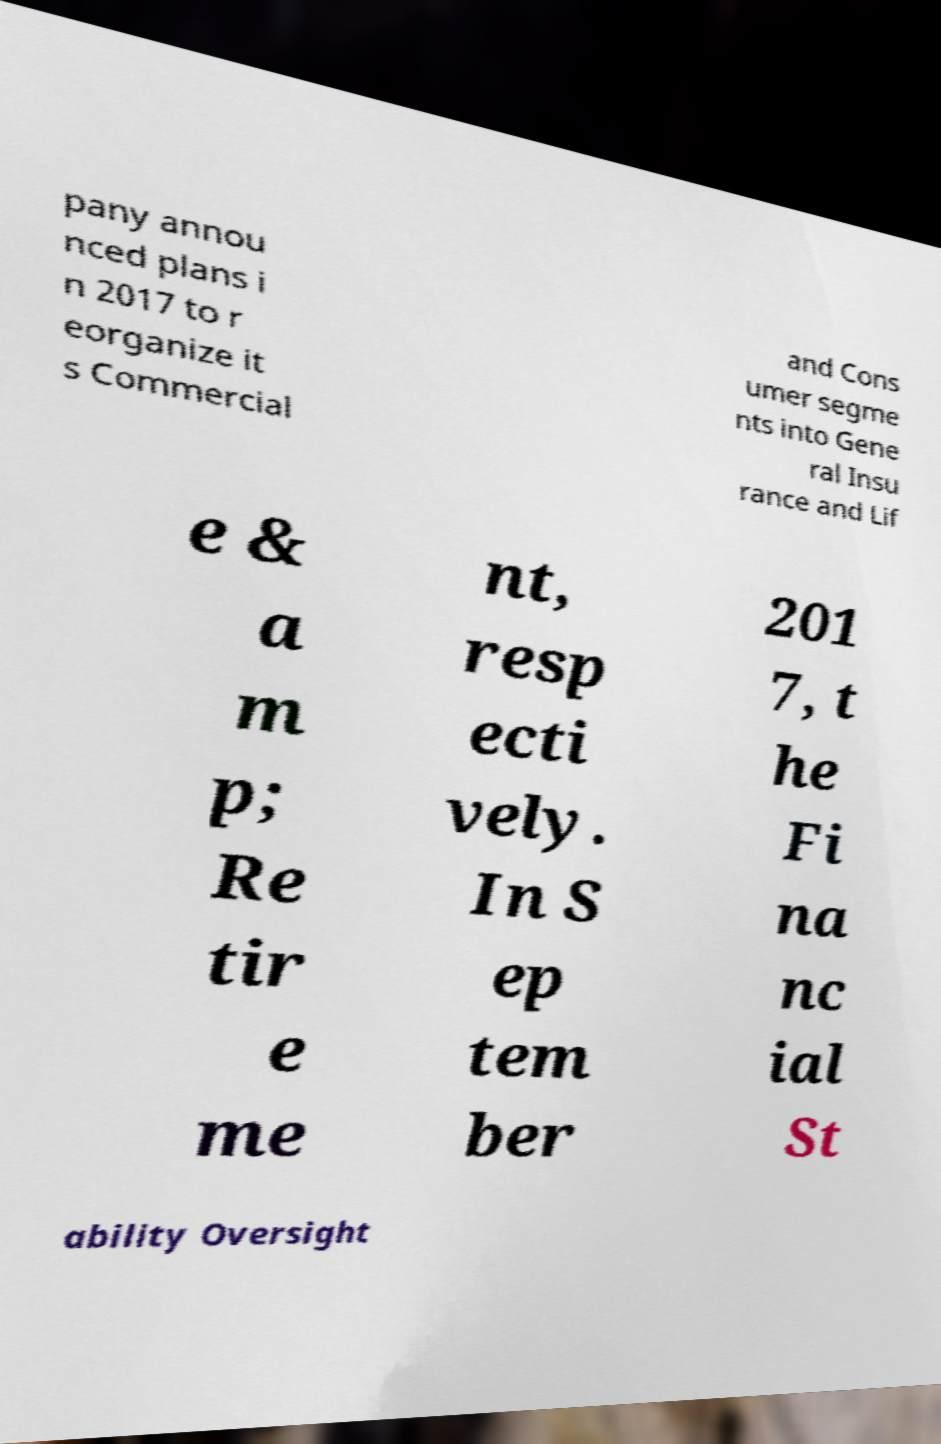For documentation purposes, I need the text within this image transcribed. Could you provide that? pany annou nced plans i n 2017 to r eorganize it s Commercial and Cons umer segme nts into Gene ral Insu rance and Lif e & a m p; Re tir e me nt, resp ecti vely. In S ep tem ber 201 7, t he Fi na nc ial St ability Oversight 